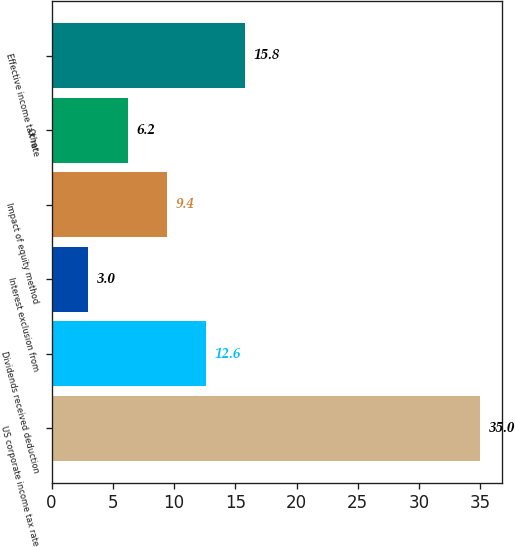<chart> <loc_0><loc_0><loc_500><loc_500><bar_chart><fcel>US corporate income tax rate<fcel>Dividends received deduction<fcel>Interest exclusion from<fcel>Impact of equity method<fcel>Other<fcel>Effective income tax rate<nl><fcel>35<fcel>12.6<fcel>3<fcel>9.4<fcel>6.2<fcel>15.8<nl></chart> 